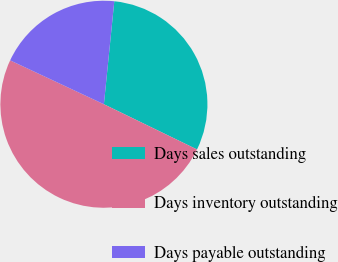<chart> <loc_0><loc_0><loc_500><loc_500><pie_chart><fcel>Days sales outstanding<fcel>Days inventory outstanding<fcel>Days payable outstanding<nl><fcel>30.59%<fcel>49.77%<fcel>19.63%<nl></chart> 